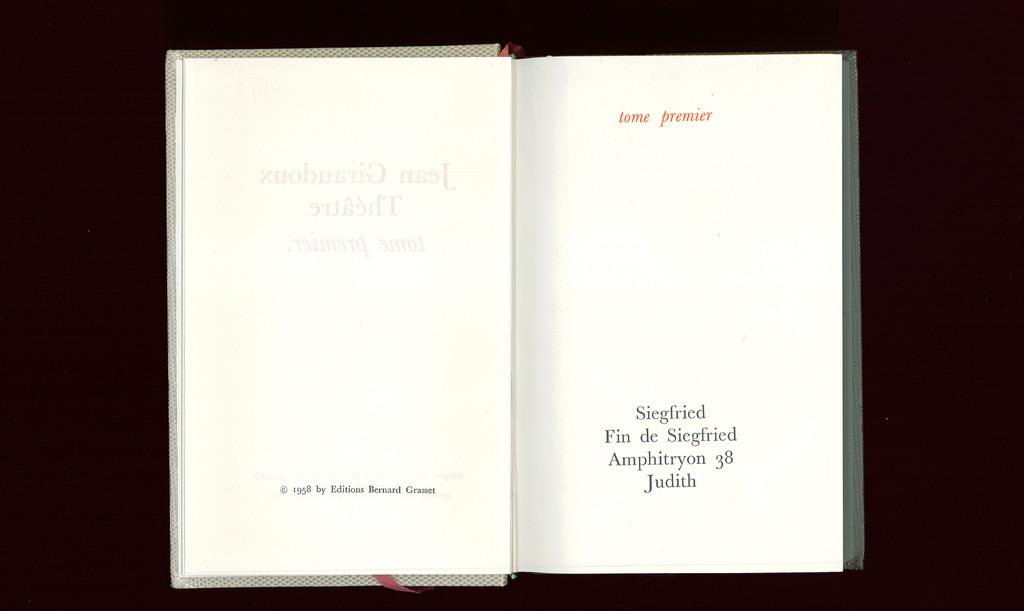<image>
Provide a brief description of the given image. Tome premier appears in red on the right side of an open book. 